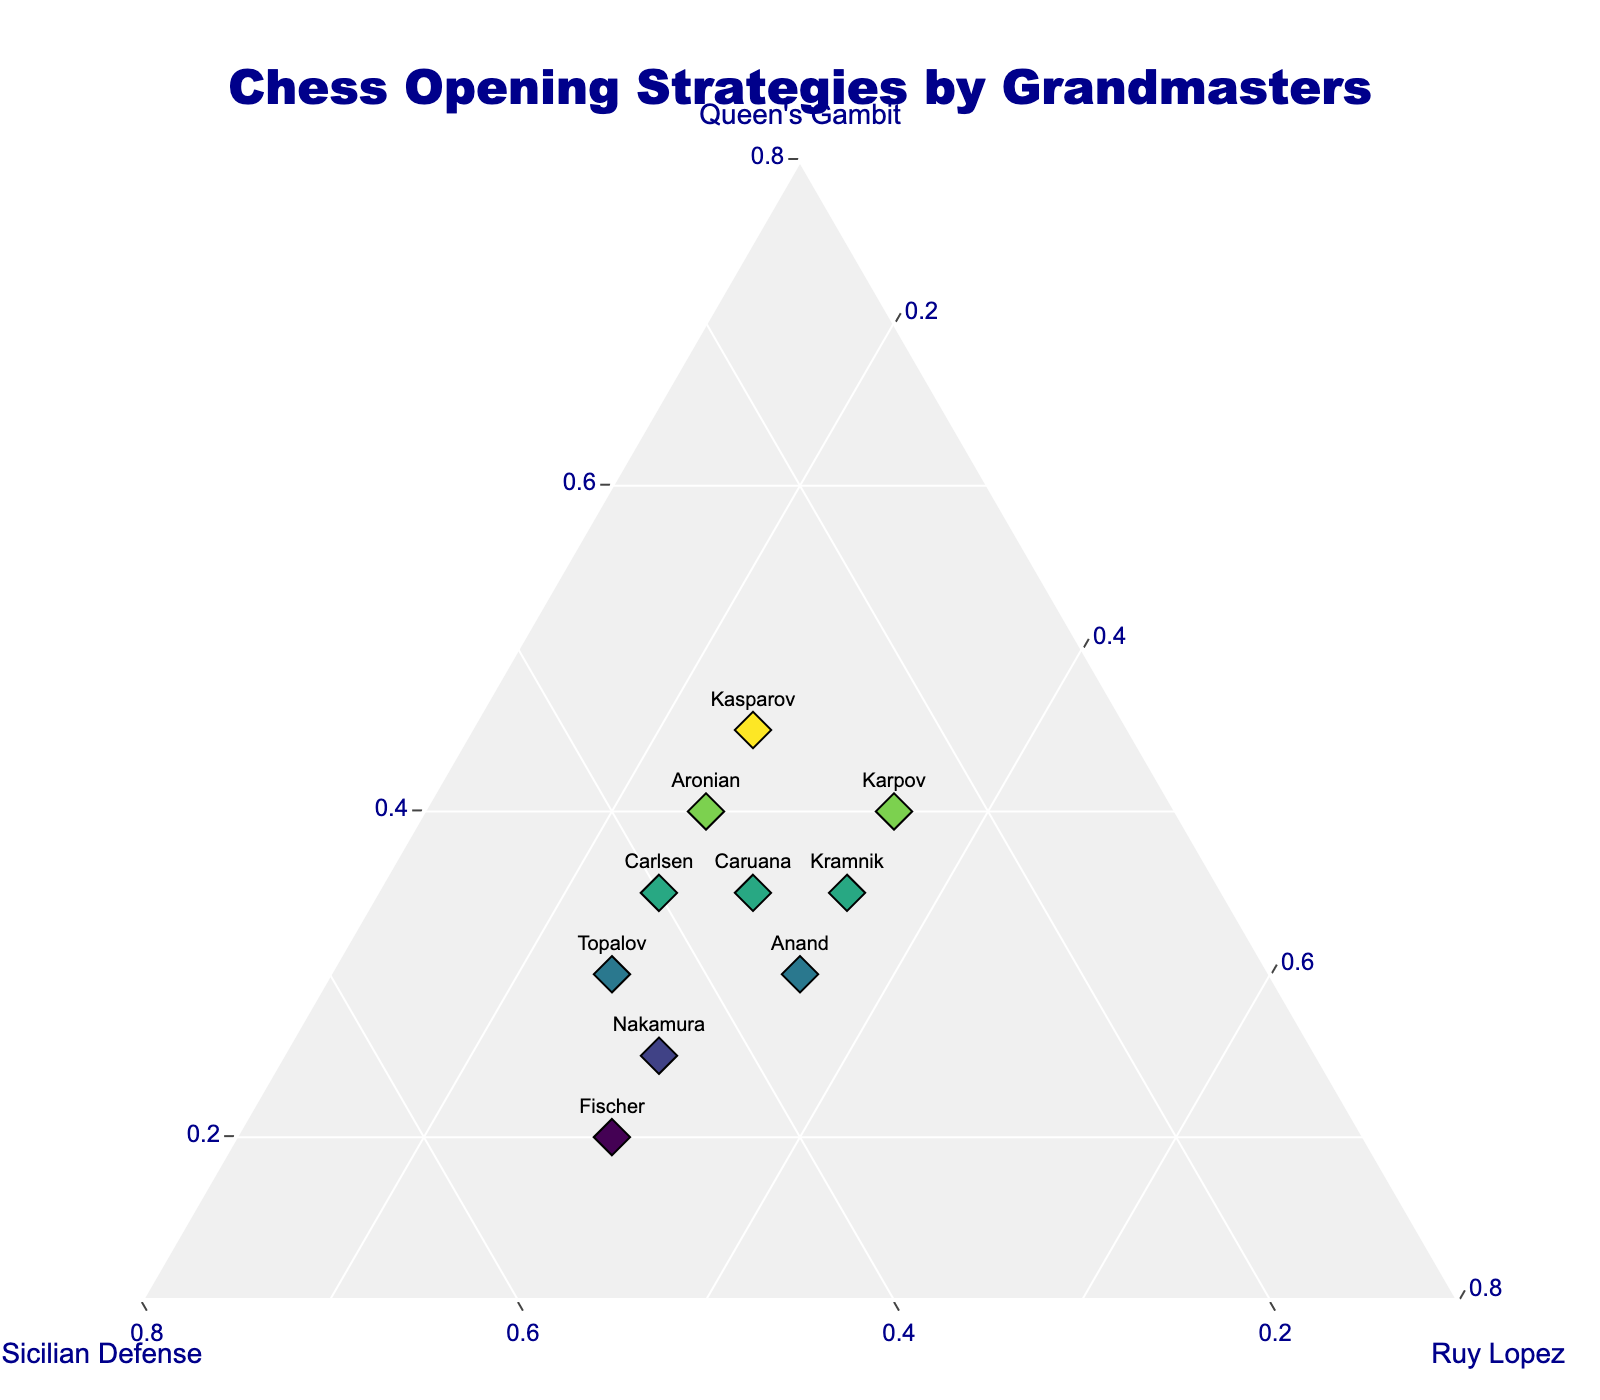What is the most commonly used opening strategy among the grandmasters shown in the plot? To find the most commonly used opening strategy, look for the point along each axis where the majority of grandmasters cluster. The Queen's Gambit has more data points positioned more prominently among grandmasters.
Answer: Queen's Gambit Which grandmaster uses the Sicilian Defense the most? Identify the grandmaster whose representative point is closest to the Sicilian Defense axis. Fischer's point is very close to the b-axis indicating higher use of the Sicilian Defense compared to others.
Answer: Fischer Which two grandmasters have the same preference for the Ruy Lopez strategy? Compare the coordinates for multiple points along the Ruy Lopez (c-axis). Both Anand and Kramnik have a value of 0.35 for the Ruy Lopez strategy.
Answer: Anand and Kramnik What is the sum of the percentages for Queen's Gambit used by Kasparov and Karpov? Add the values for Queen's Gambit used by Kasparov (0.45) and Karpov (0.40). (0.45 + 0.4 = 0.85)
Answer: 0.85 (or 85%) Which grandmaster uses the Queen's Gambit slightly more than the Sicilian Defense but less than the Ruy Lopez? Look for a grandmaster whose Queen's Gambit value is slightly higher than the Sicilian Defense value, and both are lower than the Ruy Lopez value. Anand has these values (0.30, 0.35, 0.35) making 0.35 for Ruy Lopez higher.
Answer: Anand Compare Carlsen and Topalov's use of the Sicilian Defense. Who uses it more? Check the Sicilian Defense values for Carlsen (0.40) and Topalov (0.45). Since 0.45 is greater than 0.40, Topalov uses it more.
Answer: Topalov Which opening strategy does Caruana have a balanced preference across? Look for a grandmaster with nearly equal values across all strategies. Caruana has values (0.35, 0.35, 0.30), which are quite balanced across all strategies.
Answer: All of them (Queen's Gambit, Sicilian Defense, Ruy Lopez) What is the median value of Ruy Lopez strategy usage among the grandmasters shown? To find the median, list all the values of Ruy Lopez usage and find the middle value. Sorted values: (0.25, 0.25, 0.25, 0.25, 0.30, 0.30, 0.30, 0.35, 0.35, 0.35). The median is the average of the 5th and 6th values: (0.30 + 0.30)/2 = 0.30
Answer: 0.30 (or 30%) Which grandmaster has the least variance in the usage of the three strategies? Identify who has the closest values for all three strategies. Caruana has (0.35, 0.35, 0.30) which are very close, indicating the least variance.
Answer: Caruana How many grandmasters use the Ruy Lopez less than 0.30? Count the number of grandmasters who have values lower than 0.30 for Ruy Lopez. Kasparov, Carlsen, Topalov, and Aronian have values less than 0.30 for Ruy Lopez.
Answer: 4 